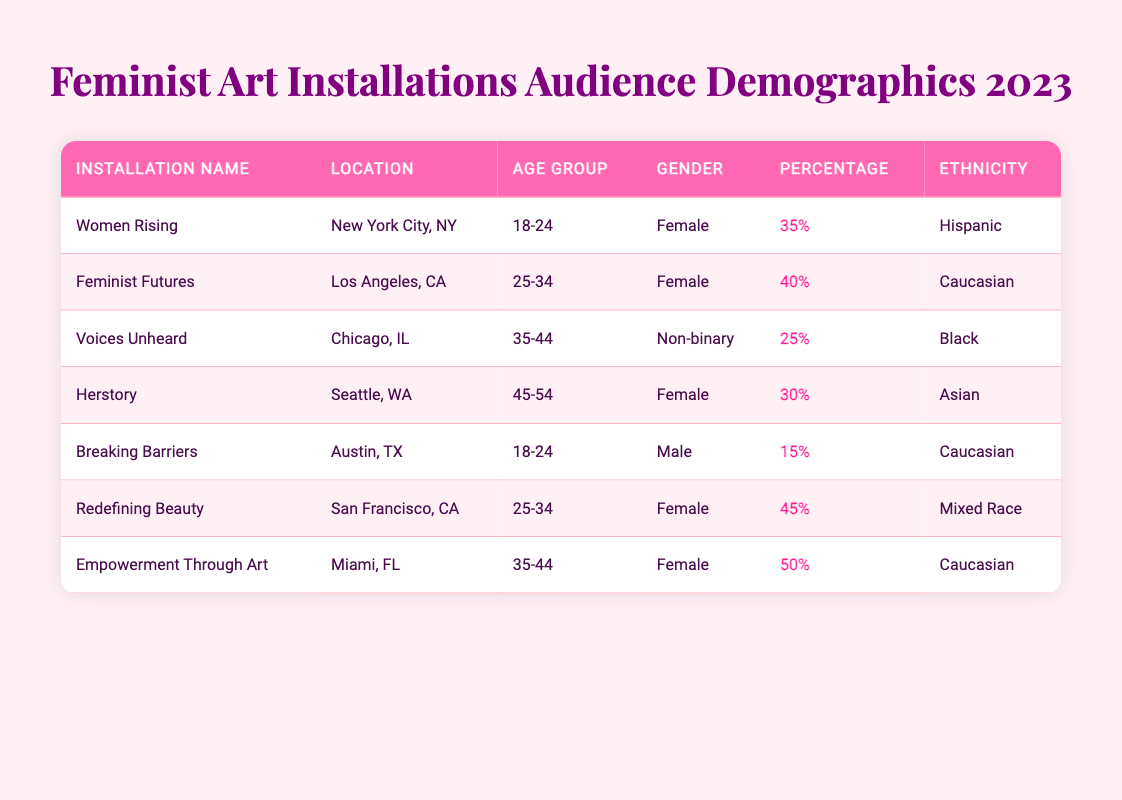What is the percentage of the audience for the installation "Women Rising"? From the table, we can see that under the installation "Women Rising," the percentage listed is 35%. Therefore, the specific percentage of the audience drawn to this installation is directly referenced.
Answer: 35% Which installation attracted the highest percentage of female audience members? Looking at the table, we see that "Empowerment Through Art" has a percentage of 50% and is focused on a female audience. We can conclude it is the highest compared to other female-focused installations.
Answer: Empowerment Through Art How many installations had at least a 40% audience from the age group 25-34? By evaluating the installations in the age group of 25-34, we find two installations: "Feminist Futures" (40%) and "Redefining Beauty" (45%). Adding them gives us a total of 2 installations meeting this criterion.
Answer: 2 Is there a significant representation of non-binary individuals among the audience for any of the installations? The table highlights only one installation, "Voices Unheard," where 25% of the audience is non-binary. This indicates that while there is representation, it is limited to a single installation.
Answer: Yes What is the average percentage of the female audience across all installations? To calculate the average percentage of female audience members, we first identify the installations with female representation: "Women Rising" (35%), "Feminist Futures" (40%), "Herstory" (30%), "Redefining Beauty" (45%), and "Empowerment Through Art" (50%). The total of these percentages is 200%. Dividing by 5 (the number of installations) yields an average of 40%.
Answer: 40% 